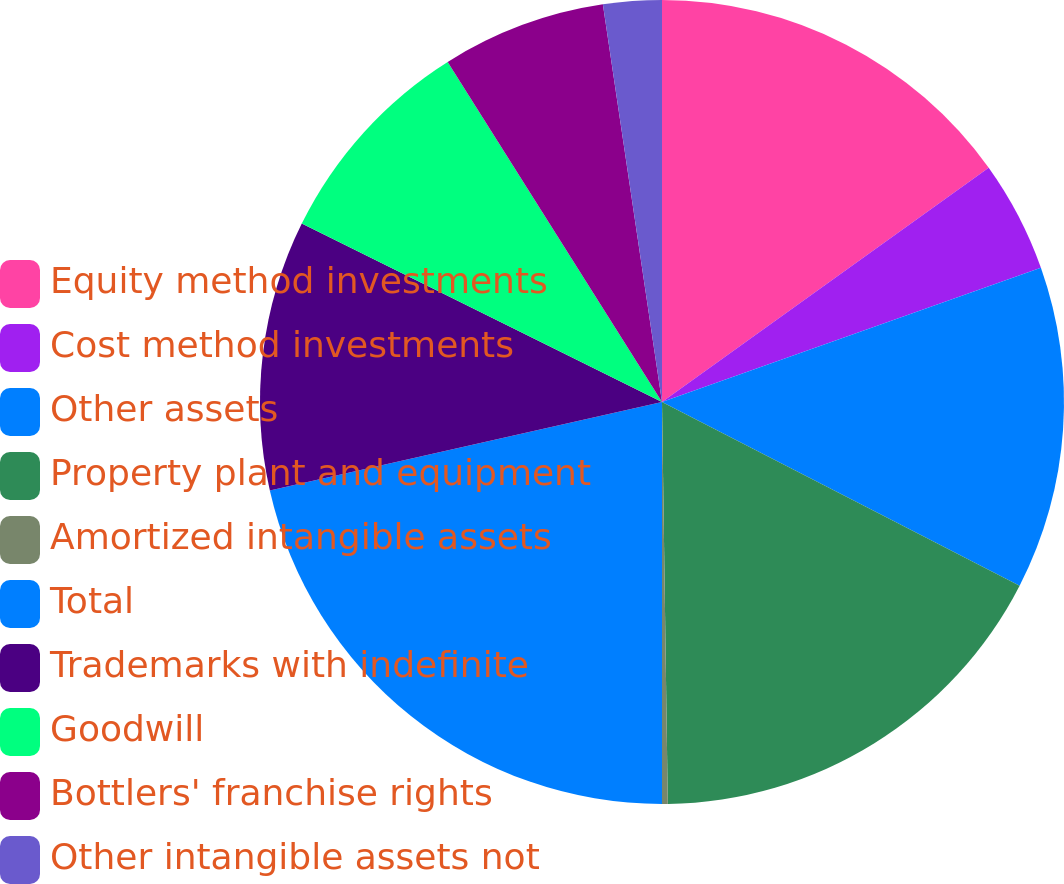Convert chart to OTSL. <chart><loc_0><loc_0><loc_500><loc_500><pie_chart><fcel>Equity method investments<fcel>Cost method investments<fcel>Other assets<fcel>Property plant and equipment<fcel>Amortized intangible assets<fcel>Total<fcel>Trademarks with indefinite<fcel>Goodwill<fcel>Bottlers' franchise rights<fcel>Other intangible assets not<nl><fcel>15.1%<fcel>4.48%<fcel>12.97%<fcel>17.22%<fcel>0.23%<fcel>21.47%<fcel>10.85%<fcel>8.73%<fcel>6.6%<fcel>2.35%<nl></chart> 